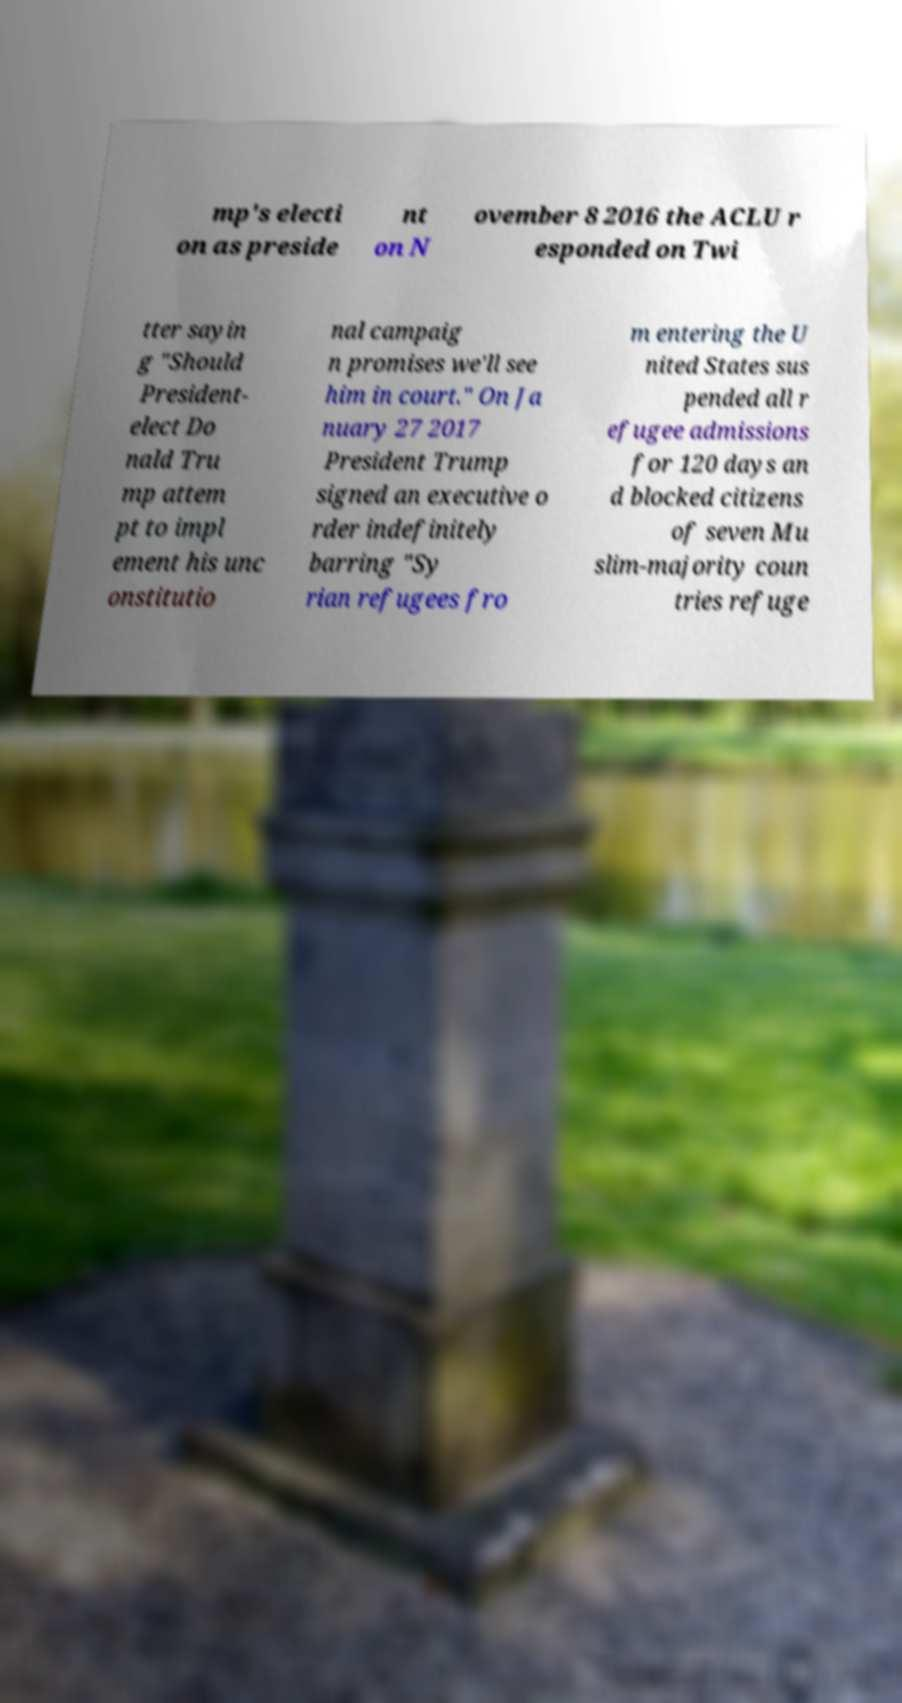Please read and relay the text visible in this image. What does it say? mp's electi on as preside nt on N ovember 8 2016 the ACLU r esponded on Twi tter sayin g "Should President- elect Do nald Tru mp attem pt to impl ement his unc onstitutio nal campaig n promises we'll see him in court." On Ja nuary 27 2017 President Trump signed an executive o rder indefinitely barring "Sy rian refugees fro m entering the U nited States sus pended all r efugee admissions for 120 days an d blocked citizens of seven Mu slim-majority coun tries refuge 